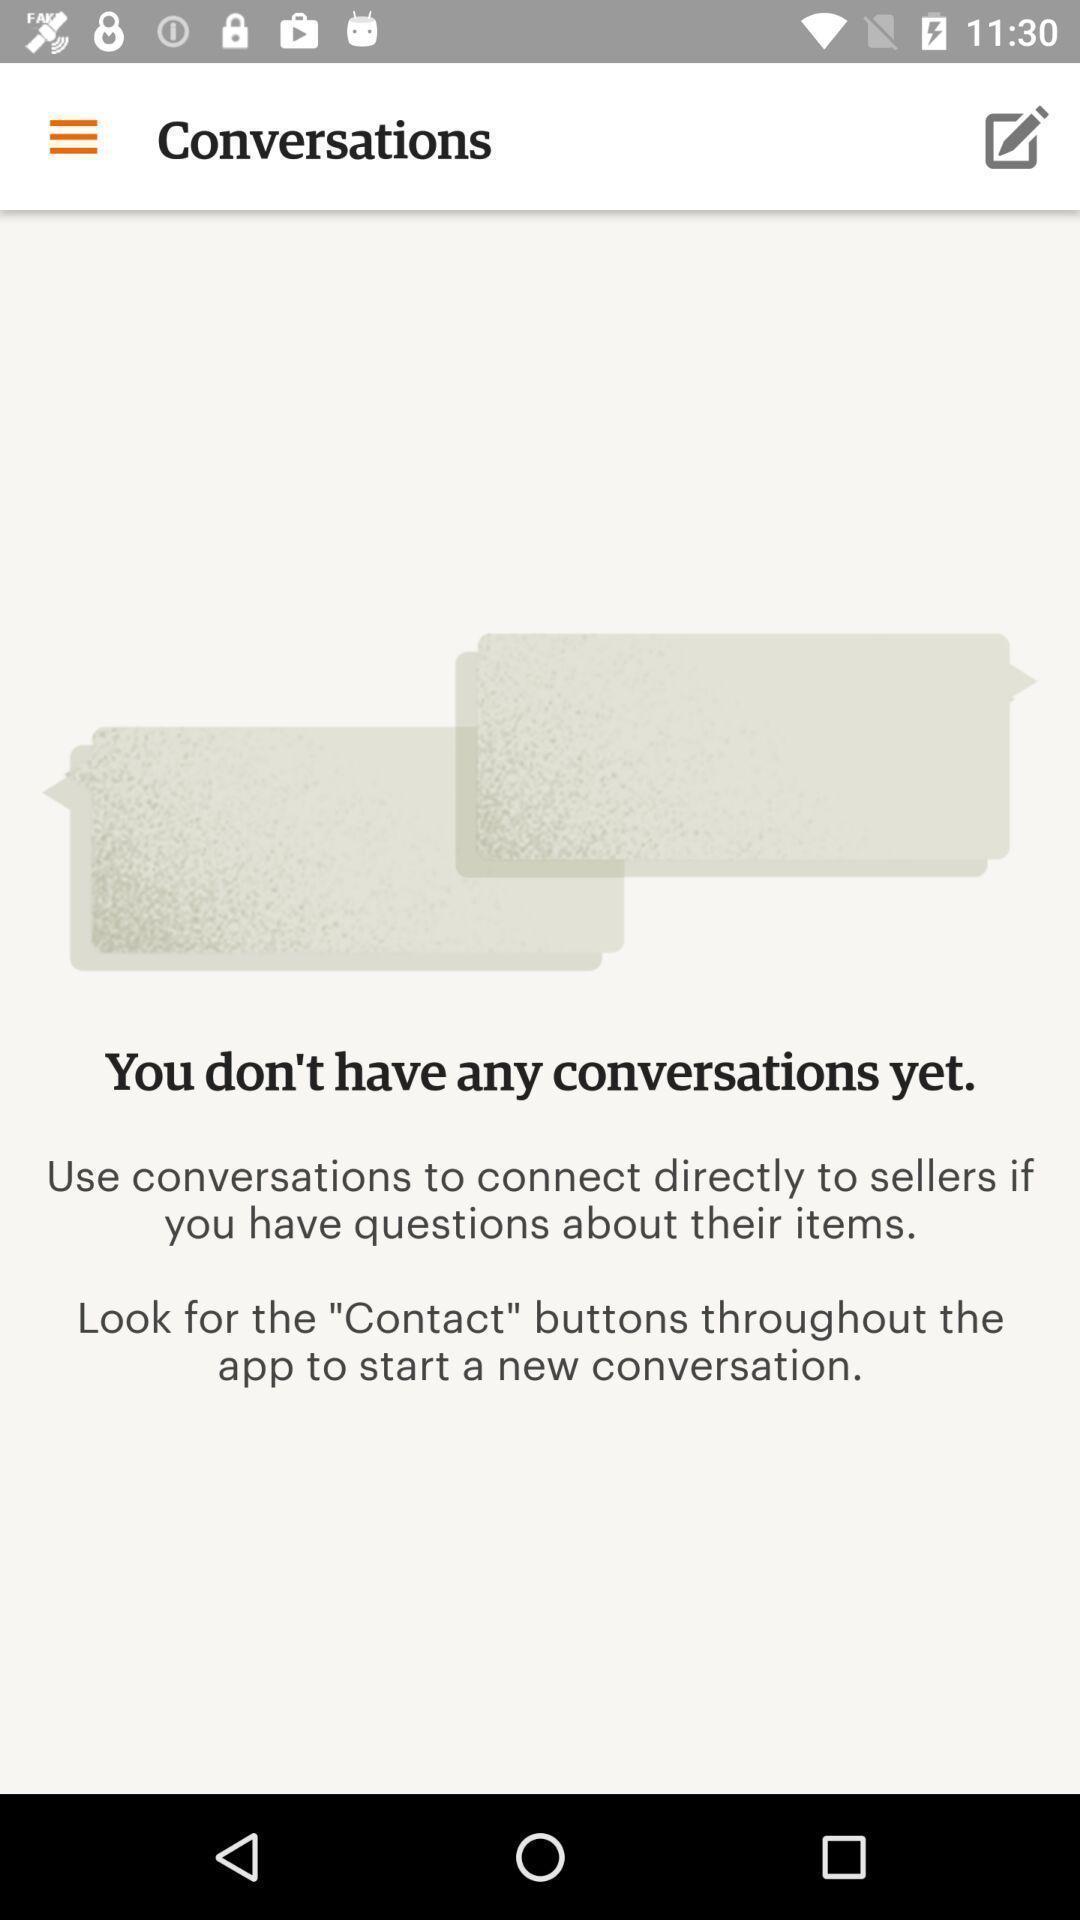Provide a detailed account of this screenshot. Screen displaying conversations. 